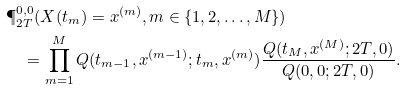<formula> <loc_0><loc_0><loc_500><loc_500>& \P ^ { 0 , 0 } _ { 2 T } ( X ( t _ { m } ) = x ^ { ( m ) } , m \in \{ 1 , 2 , \dots , M \} ) \\ & \quad = \prod _ { m = 1 } ^ { M } Q ( t _ { m - 1 } , x ^ { ( m - 1 ) } ; t _ { m } , x ^ { ( m ) } ) \frac { Q ( t _ { M } , x ^ { ( M ) } ; 2 T , 0 ) } { Q ( 0 , 0 ; 2 T , 0 ) } .</formula> 